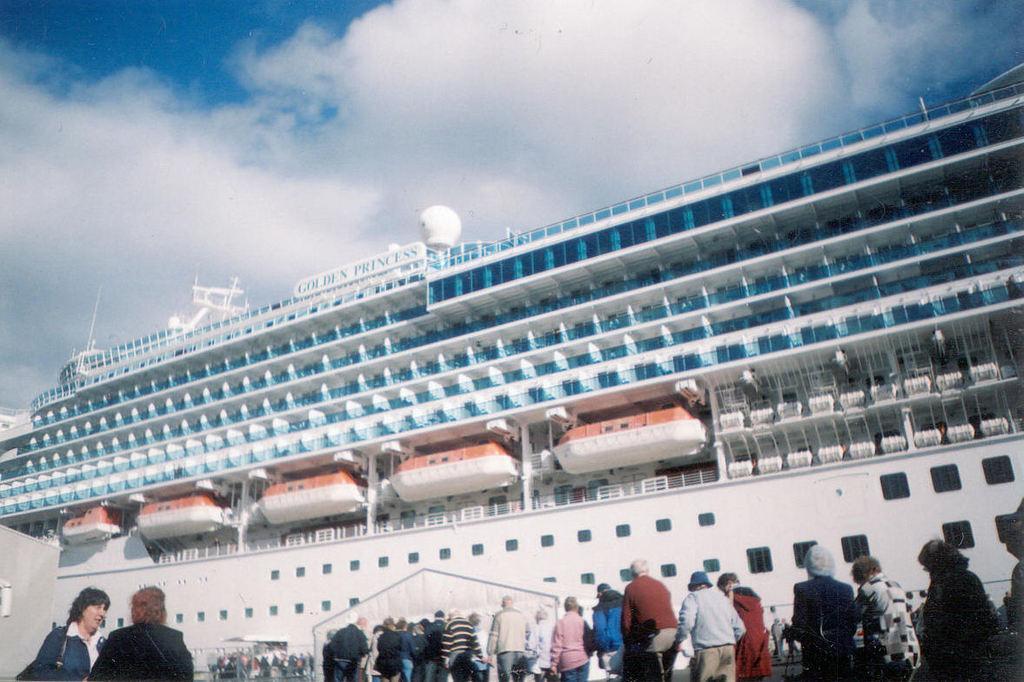Could you give a brief overview of what you see in this image? In this image we can see ship. At the bottom of the image there are persons. In the background there is sky and clouds. 